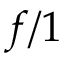Convert formula to latex. <formula><loc_0><loc_0><loc_500><loc_500>f / 1</formula> 